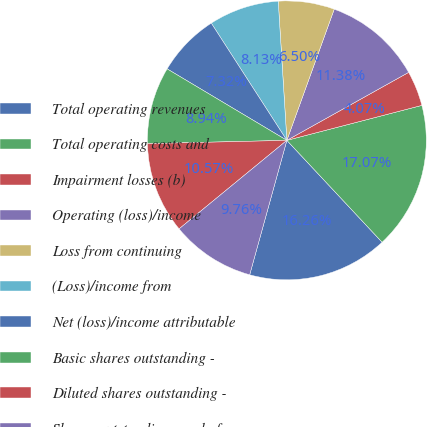<chart> <loc_0><loc_0><loc_500><loc_500><pie_chart><fcel>Total operating revenues<fcel>Total operating costs and<fcel>Impairment losses (b)<fcel>Operating (loss)/income<fcel>Loss from continuing<fcel>(Loss)/income from<fcel>Net (loss)/income attributable<fcel>Basic shares outstanding -<fcel>Diluted shares outstanding -<fcel>Shares outstanding - end of<nl><fcel>16.26%<fcel>17.07%<fcel>4.07%<fcel>11.38%<fcel>6.5%<fcel>8.13%<fcel>7.32%<fcel>8.94%<fcel>10.57%<fcel>9.76%<nl></chart> 